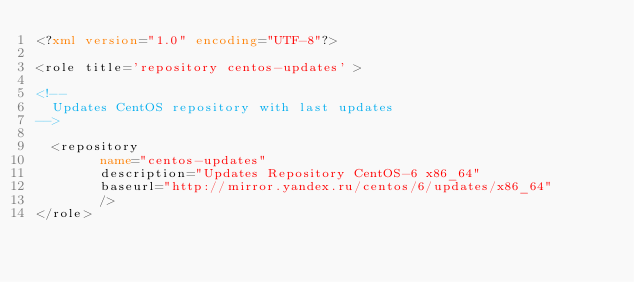Convert code to text. <code><loc_0><loc_0><loc_500><loc_500><_XML_><?xml version="1.0" encoding="UTF-8"?>

<role title='repository centos-updates' >

<!-- 
  Updates CentOS repository with last updates
-->

  <repository
        name="centos-updates" 
        description="Updates Repository CentOS-6 x86_64" 
        baseurl="http://mirror.yandex.ru/centos/6/updates/x86_64"
        />
</role>
</code> 